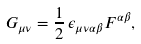<formula> <loc_0><loc_0><loc_500><loc_500>G _ { \mu \nu } = \frac { 1 } { 2 } \, \epsilon _ { \mu \nu \alpha \beta } F ^ { \alpha \beta } ,</formula> 